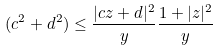Convert formula to latex. <formula><loc_0><loc_0><loc_500><loc_500>( c ^ { 2 } + d ^ { 2 } ) \leq \frac { | c z + d | ^ { 2 } } { y } \frac { 1 + | z | ^ { 2 } } { y }</formula> 